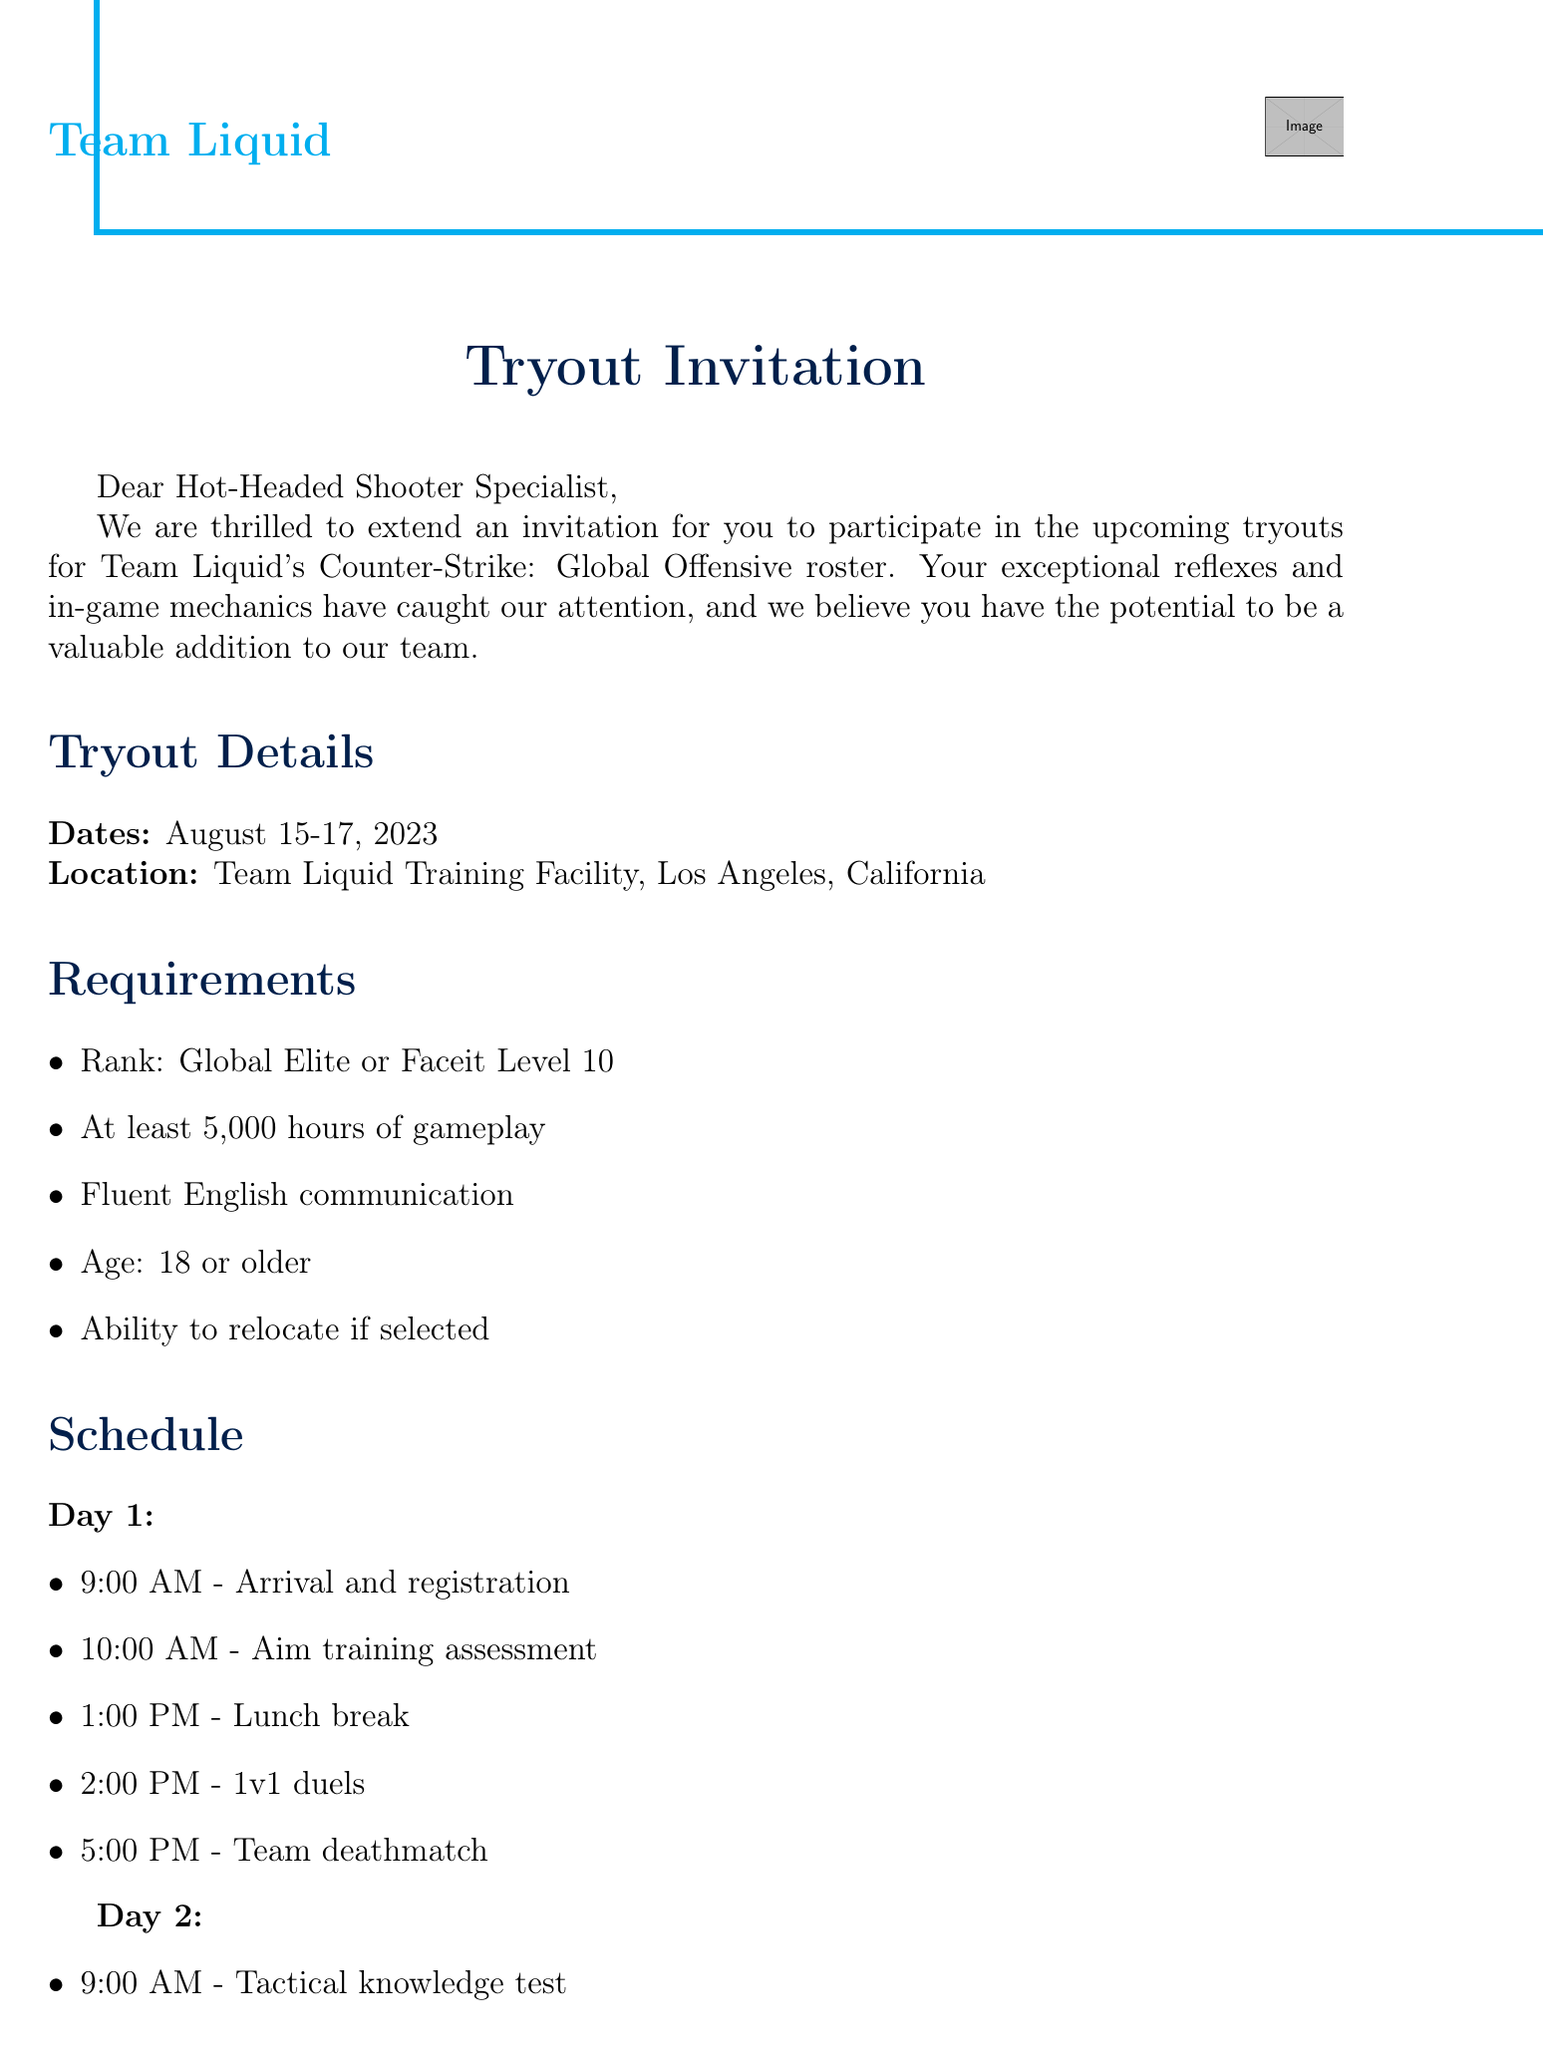What are the tryout dates? The tryout dates for Team Liquid are mentioned as August 15-17, 2023.
Answer: August 15-17, 2023 What is the location of the tryouts? The document states that the location for the tryouts is the Team Liquid Training Facility in Los Angeles, California.
Answer: Team Liquid Training Facility, Los Angeles, California What is the minimum rank required? The document specifies that the minimum rank required is Global Elite or Faceit Level 10.
Answer: Global Elite or Faceit Level 10 How many hours of gameplay are required? According to the document, at least 5,000 hours of gameplay are required for participation in the tryouts.
Answer: 5,000 hours What is the age requirement for participants? The document indicates that participants must be 18 years or older to qualify for the tryouts.
Answer: 18 or older What is the first activity on Day 1? The first activity listed for Day 1 is the arrival and registration at 9:00 AM.
Answer: Arrival and registration Who is the contact person for the tryouts? The contact person mentioned in the document is Sarah Thompson, Team Liquid Talent Scout.
Answer: Sarah Thompson What is one potential benefit mentioned? The document lists multiple potential benefits, including a competitive salary.
Answer: Competitive salary What type of atmosphere can participants expect? The document describes a professional training environment as part of the potential benefits for participants.
Answer: Professional training environment 